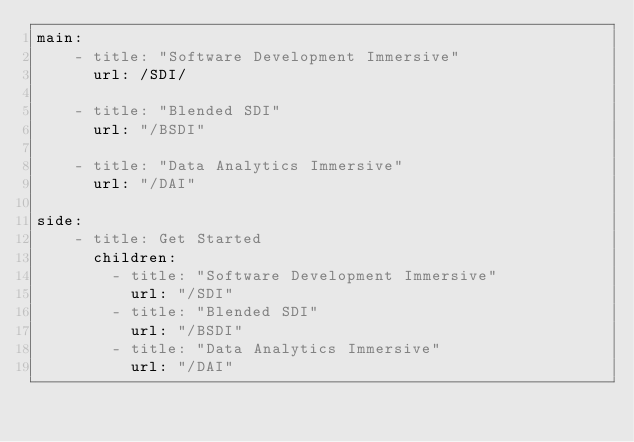<code> <loc_0><loc_0><loc_500><loc_500><_YAML_>main:
    - title: "Software Development Immersive"
      url: /SDI/

    - title: "Blended SDI"
      url: "/BSDI"

    - title: "Data Analytics Immersive"
      url: "/DAI"

side:
    - title: Get Started
      children:
        - title: "Software Development Immersive"
          url: "/SDI"
        - title: "Blended SDI"
          url: "/BSDI"
        - title: "Data Analytics Immersive"
          url: "/DAI"
</code> 